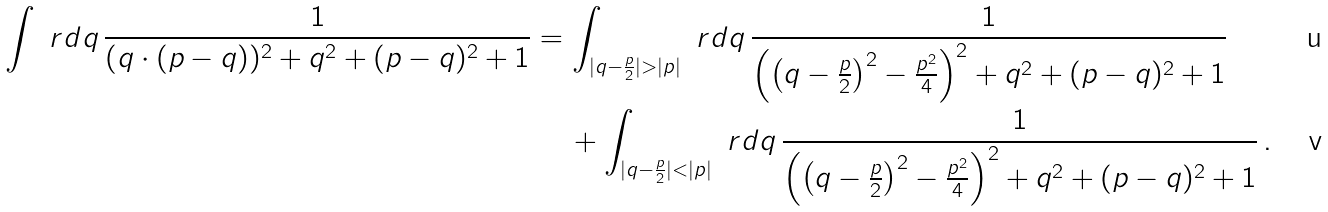<formula> <loc_0><loc_0><loc_500><loc_500>\int \ r d q \, \frac { 1 } { ( q \cdot ( p - q ) ) ^ { 2 } + q ^ { 2 } + ( p - q ) ^ { 2 } + 1 } = \, & \int _ { | q - \frac { p } { 2 } | > | p | } \ r d q \, \frac { 1 } { \left ( \left ( q - \frac { p } { 2 } \right ) ^ { 2 } - \frac { p ^ { 2 } } { 4 } \right ) ^ { 2 } + q ^ { 2 } + ( p - q ) ^ { 2 } + 1 } \\ & + \int _ { | q - \frac { p } { 2 } | < | p | } \ r d q \, \frac { 1 } { \left ( \left ( q - \frac { p } { 2 } \right ) ^ { 2 } - \frac { p ^ { 2 } } { 4 } \right ) ^ { 2 } + q ^ { 2 } + ( p - q ) ^ { 2 } + 1 } \, .</formula> 